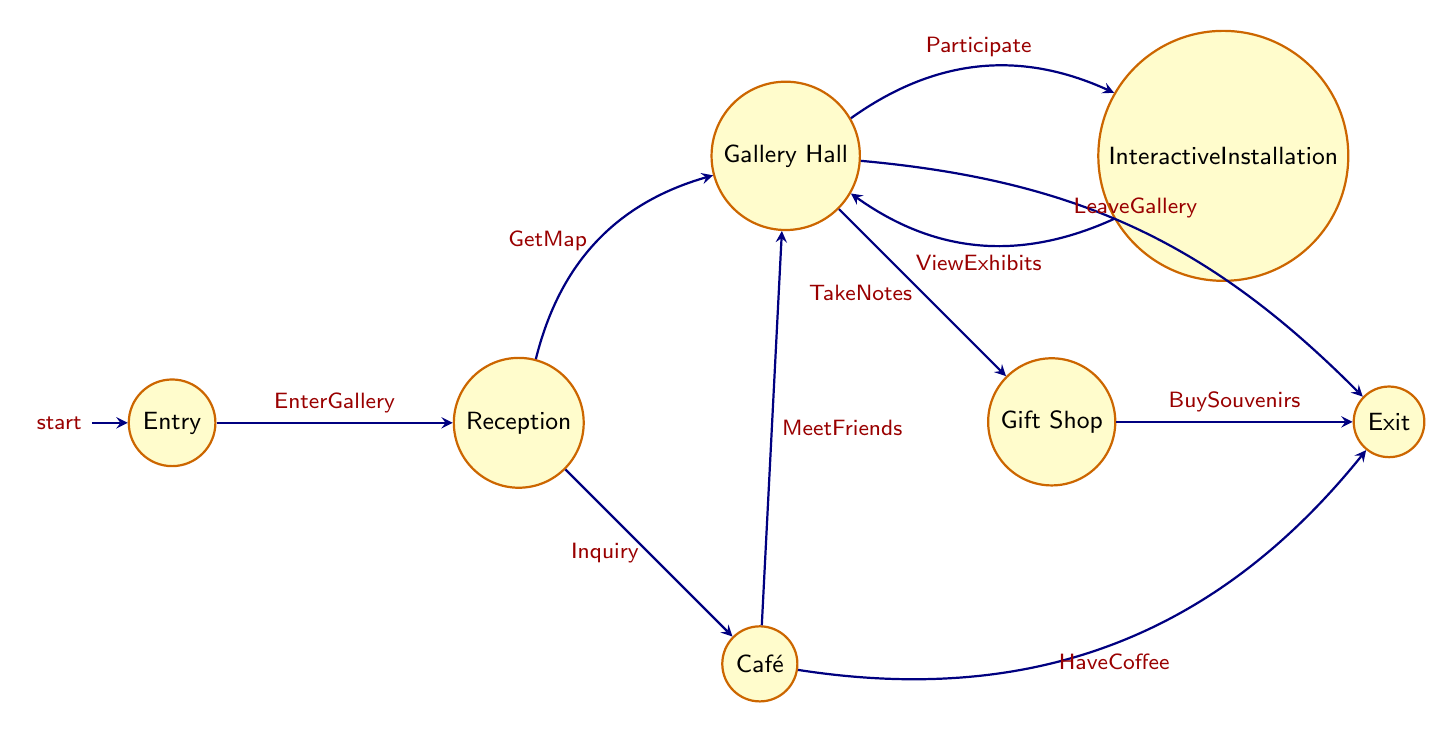What node does the visitor enter first? The visitor enters at the "Entry" node, which is the initial state of the diagram.
Answer: Entry How many nodes are in the diagram? By counting the distinct states listed in the diagram, there are a total of 7 nodes.
Answer: 7 What action occurs at the "Reception" node? The "Reception" node has two possible actions: "GetMap" and "Inquiry."
Answer: GetMap, Inquiry Which node can lead to the "Café"? The "Reception" node can lead directly to the "Café" node based on the transition paths illustrated in the diagram.
Answer: Reception What can the visitor do after viewing exhibits in the "Gallery Hall"? After viewing exhibits in the "Gallery Hall," the visitor can participate in the "Interactive Installation."
Answer: Interactive Installation What is the final action that can occur before exiting? The final action before exiting is "LeaveGallery," which connects to the "Exit" node from the "Gallery Hall."
Answer: LeaveGallery How many edges connect the "GalleryHall" to other nodes? The "GalleryHall" node connects to three other nodes: "InteractiveInstallation," "GiftShop," and "Exit," making a total of three edges.
Answer: 3 Which node can directly transition to "Exit"? The "GiftShop" node can lead directly to "Exit," and the "Café" node can also transition to "Exit."
Answer: GiftShop, Café Can a visitor return to "GalleryHall" after visiting "InteractiveInstallation"? Yes, after visiting "InteractiveInstallation," the visitor can return directly to "GalleryHall." This is highlighted by the transition arrow connecting back to the gallery.
Answer: Yes 